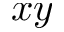Convert formula to latex. <formula><loc_0><loc_0><loc_500><loc_500>x y</formula> 